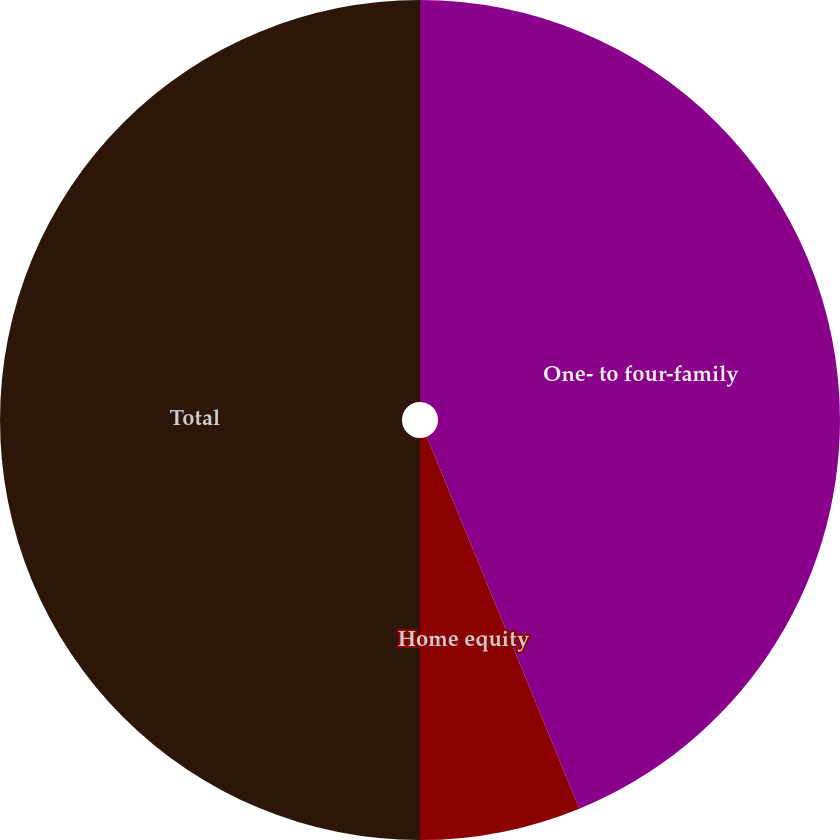Convert chart to OTSL. <chart><loc_0><loc_0><loc_500><loc_500><pie_chart><fcel>One- to four-family<fcel>Home equity<fcel>Total<nl><fcel>43.81%<fcel>6.19%<fcel>50.0%<nl></chart> 